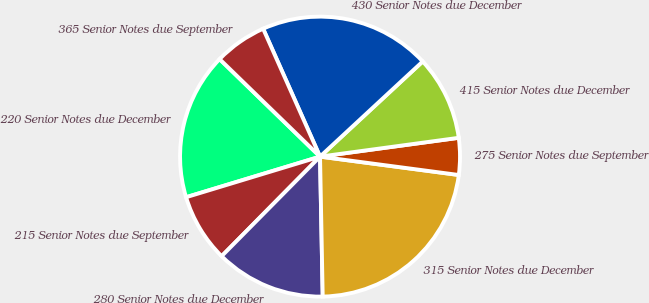<chart> <loc_0><loc_0><loc_500><loc_500><pie_chart><fcel>220 Senior Notes due December<fcel>215 Senior Notes due September<fcel>280 Senior Notes due December<fcel>315 Senior Notes due December<fcel>275 Senior Notes due September<fcel>415 Senior Notes due December<fcel>430 Senior Notes due December<fcel>365 Senior Notes due September<nl><fcel>16.95%<fcel>7.91%<fcel>12.71%<fcel>22.6%<fcel>4.24%<fcel>9.75%<fcel>19.77%<fcel>6.07%<nl></chart> 